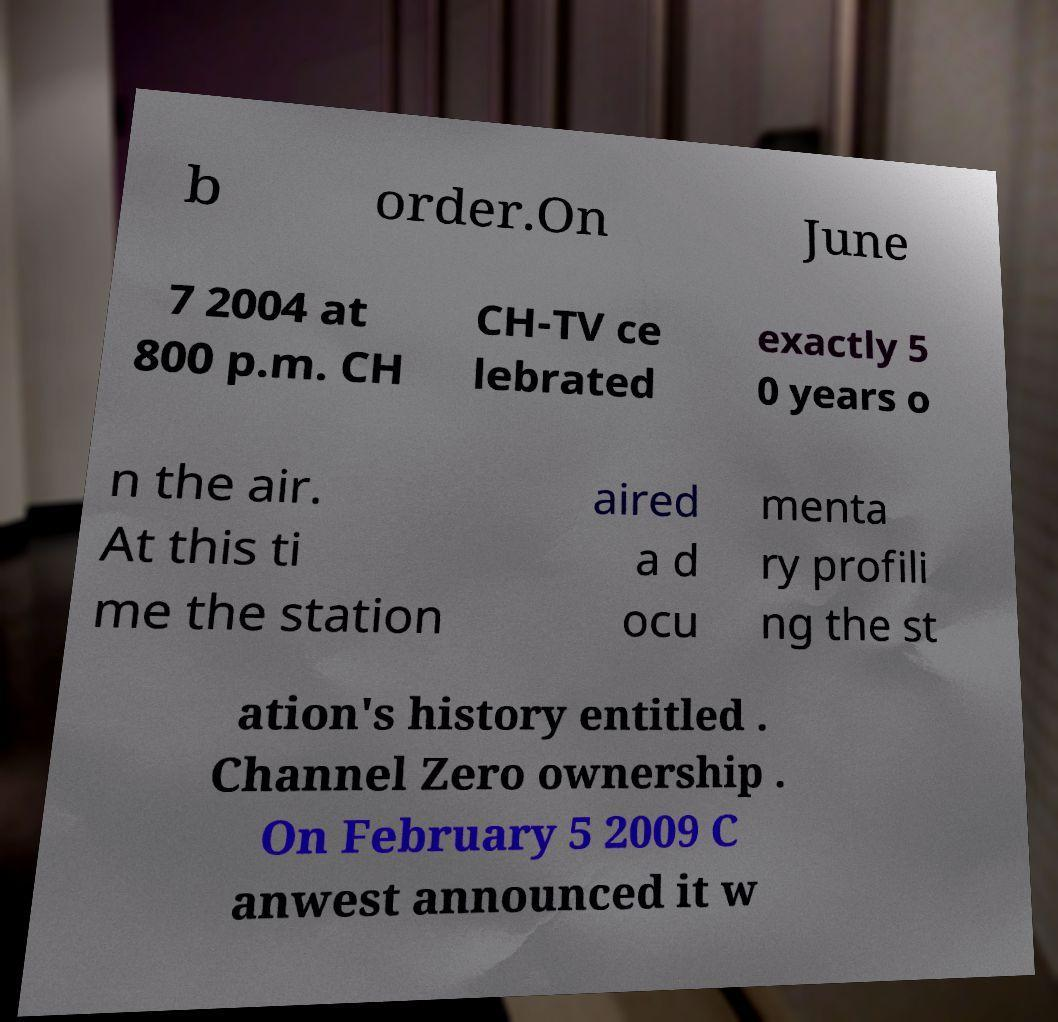Could you assist in decoding the text presented in this image and type it out clearly? b order.On June 7 2004 at 800 p.m. CH CH-TV ce lebrated exactly 5 0 years o n the air. At this ti me the station aired a d ocu menta ry profili ng the st ation's history entitled . Channel Zero ownership . On February 5 2009 C anwest announced it w 